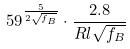Convert formula to latex. <formula><loc_0><loc_0><loc_500><loc_500>5 9 ^ { \frac { 5 } { 2 \sqrt { f _ { B } } } } \cdot \frac { 2 . 8 } { R l \sqrt { f _ { B } } }</formula> 